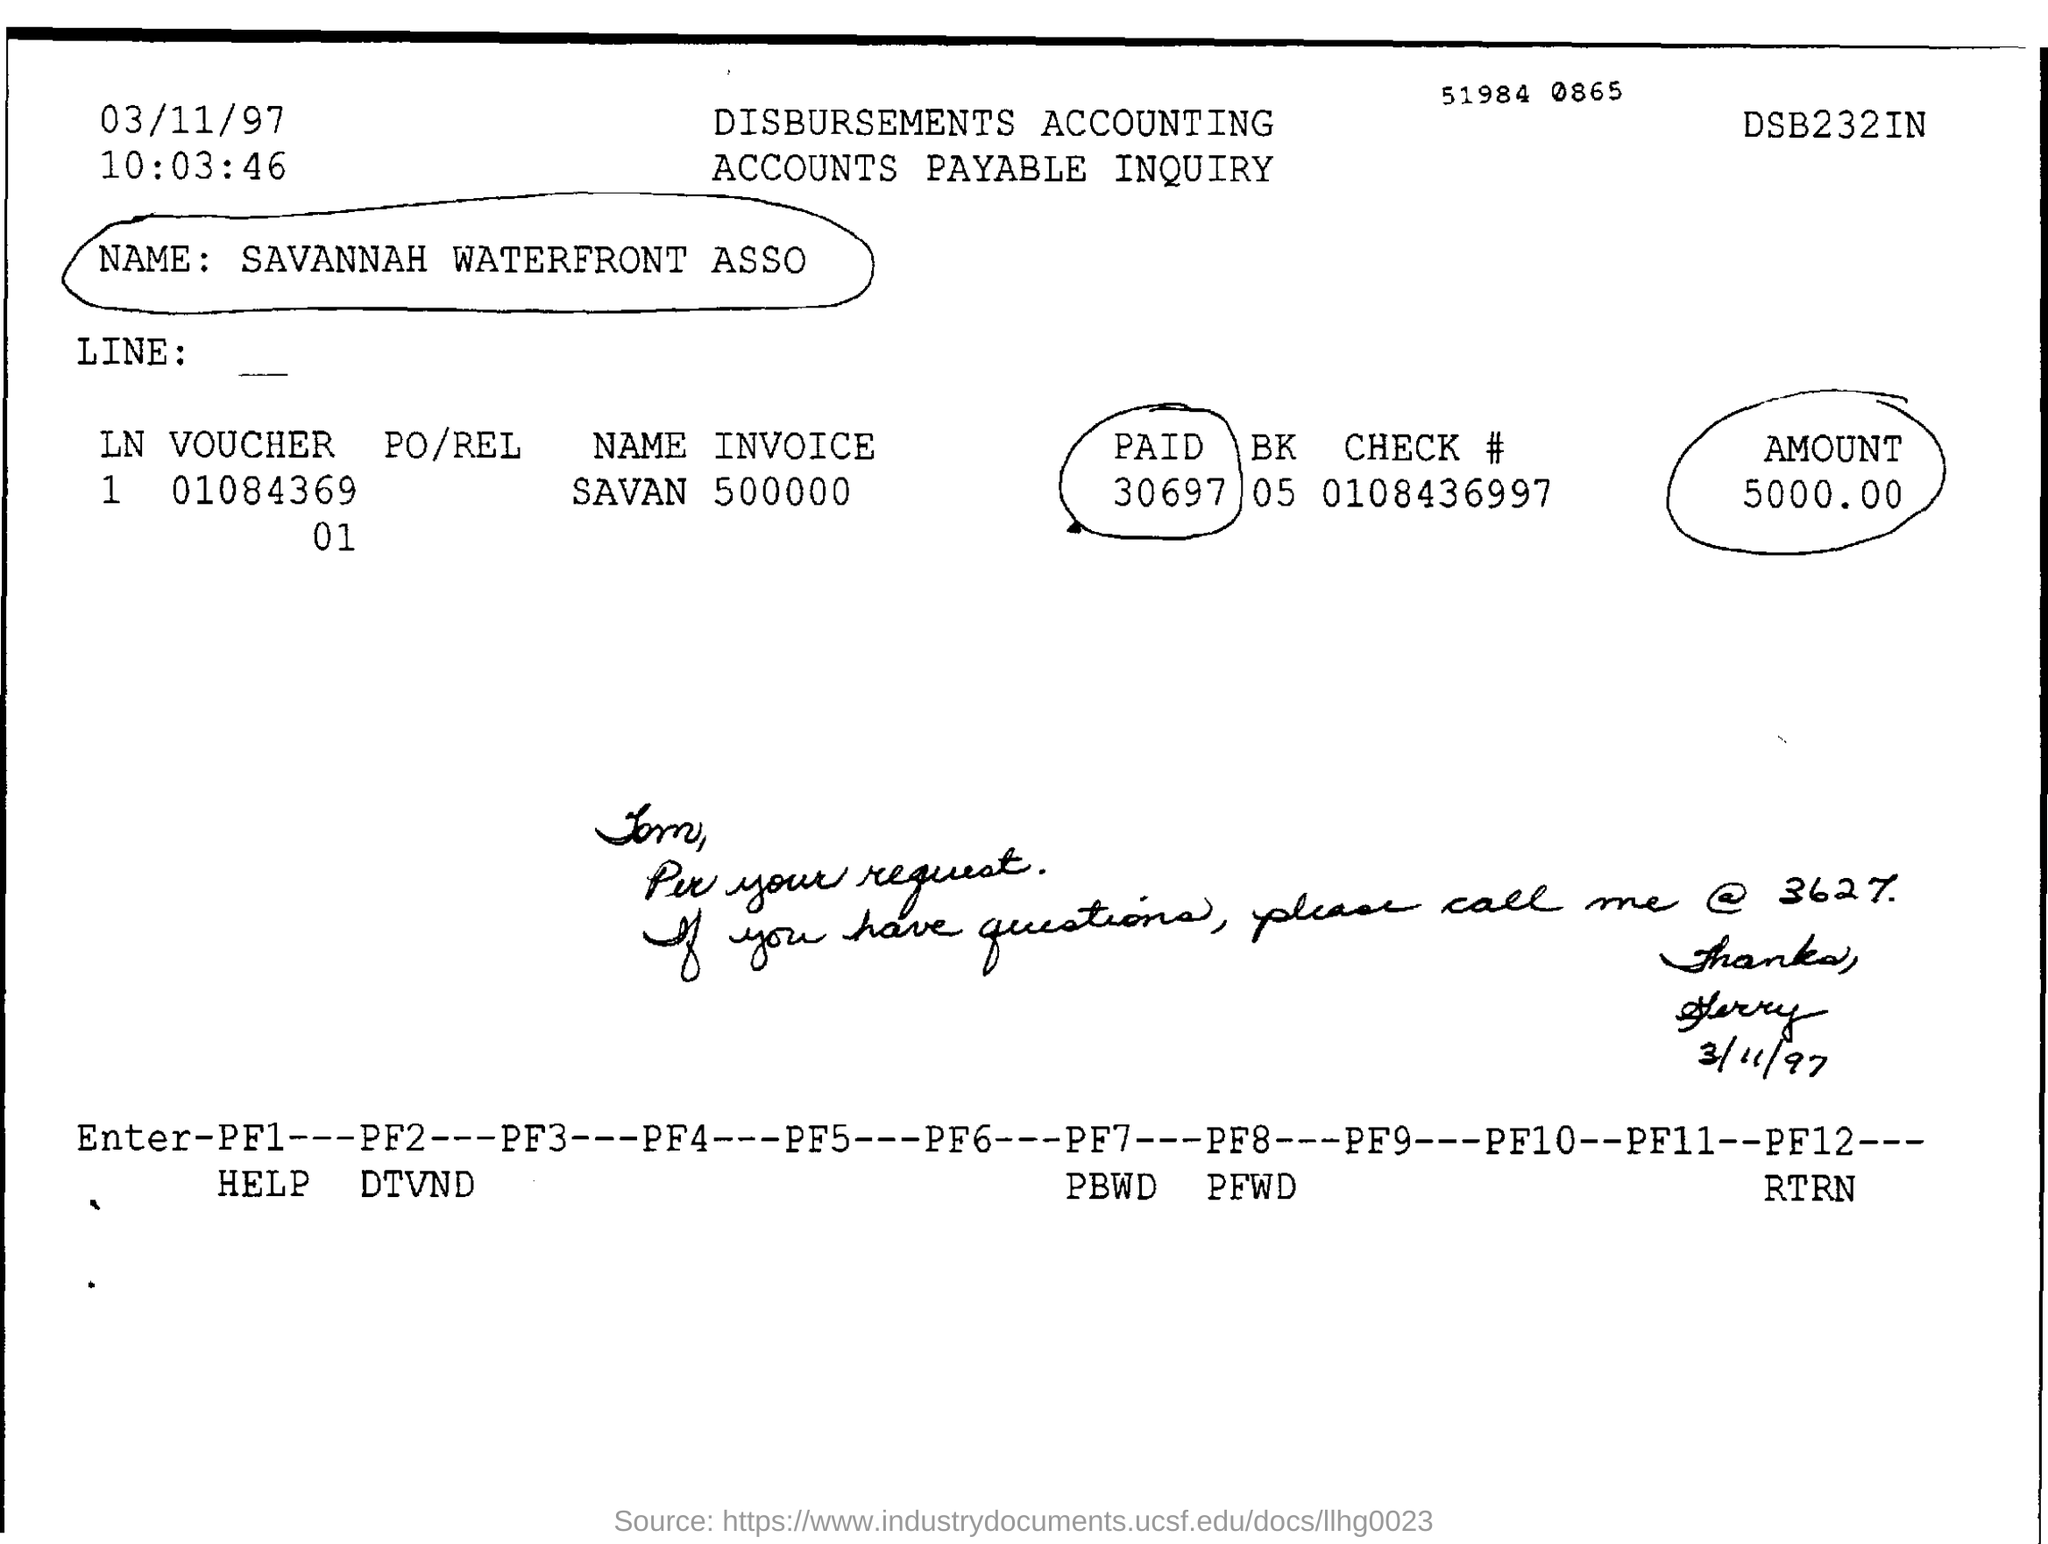What is the document title?
Offer a terse response. Disbursement Accounting Accounts Payable Inquiry. What is the name given?
Offer a terse response. SAVANNAH WATERFRONT ASSO. What is the check number?
Ensure brevity in your answer.  0108436997. What is the amount specified?
Your answer should be very brief. 5000.00. When is the document dated?
Provide a succinct answer. 03/11/97. 